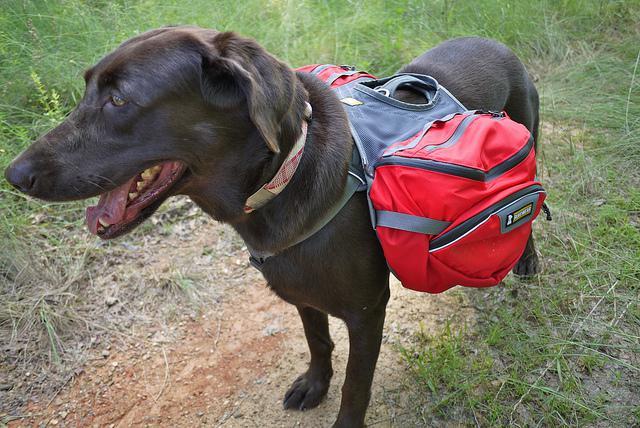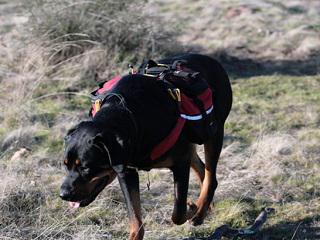The first image is the image on the left, the second image is the image on the right. For the images displayed, is the sentence "The dog on the left is wearing a back pack" factually correct? Answer yes or no. Yes. The first image is the image on the left, the second image is the image on the right. For the images shown, is this caption "There is at least one dog wearing a red pack." true? Answer yes or no. Yes. 